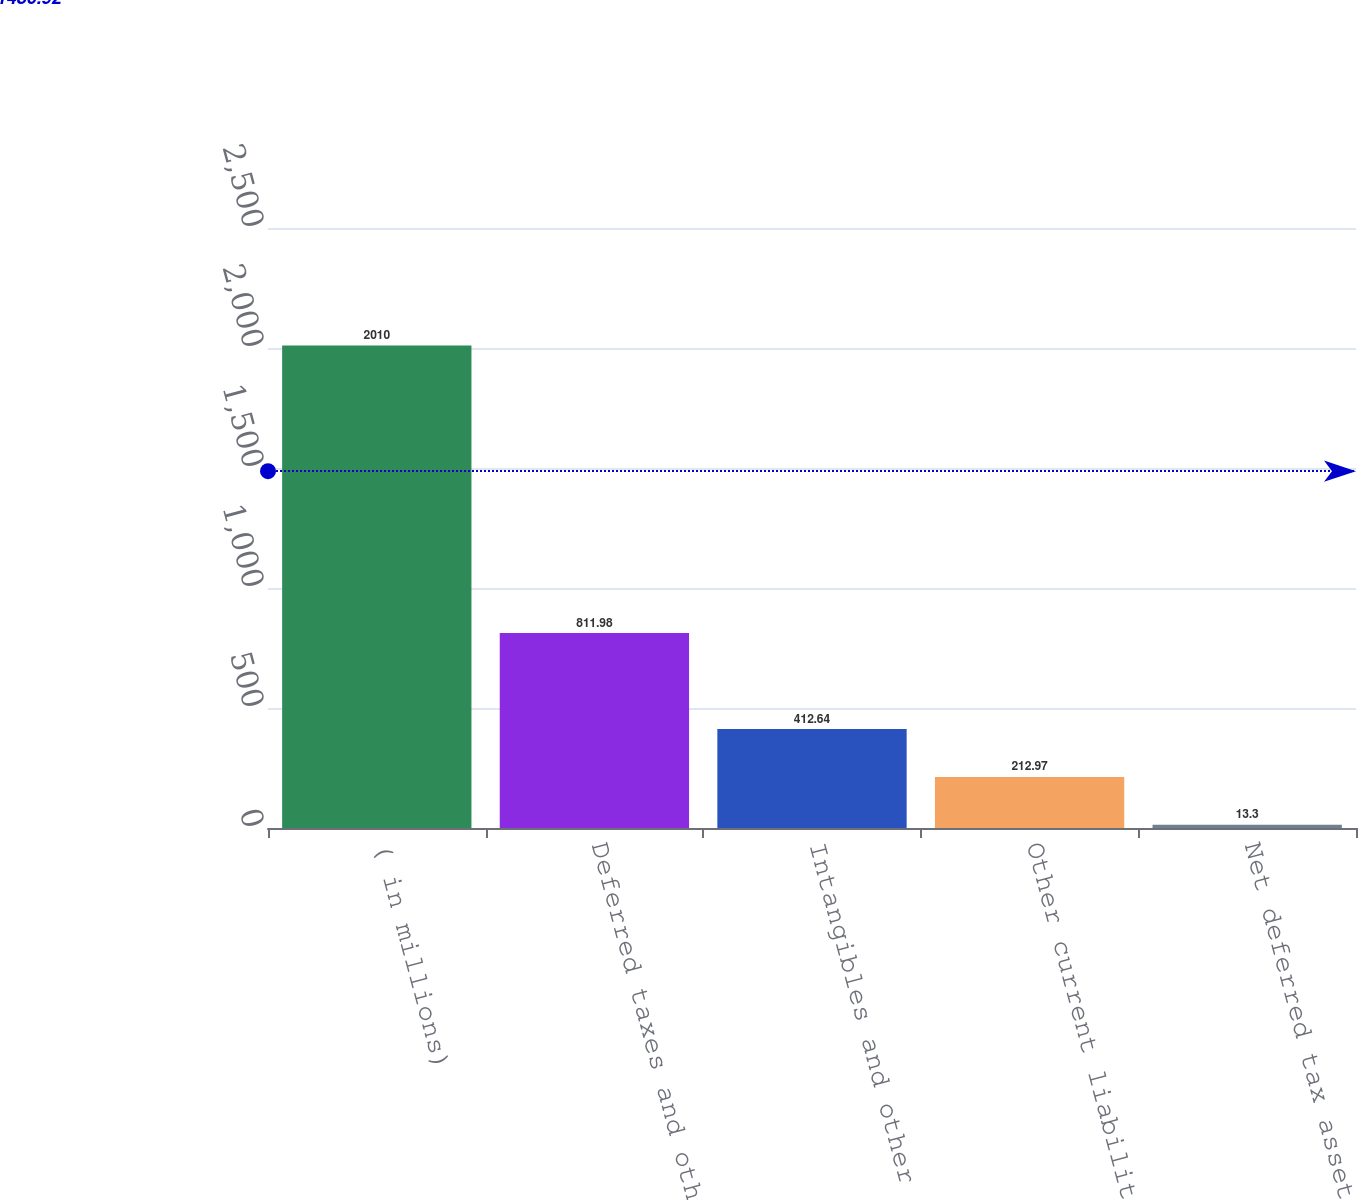Convert chart. <chart><loc_0><loc_0><loc_500><loc_500><bar_chart><fcel>( in millions)<fcel>Deferred taxes and other<fcel>Intangibles and other assets<fcel>Other current liabilities<fcel>Net deferred tax asset<nl><fcel>2010<fcel>811.98<fcel>412.64<fcel>212.97<fcel>13.3<nl></chart> 